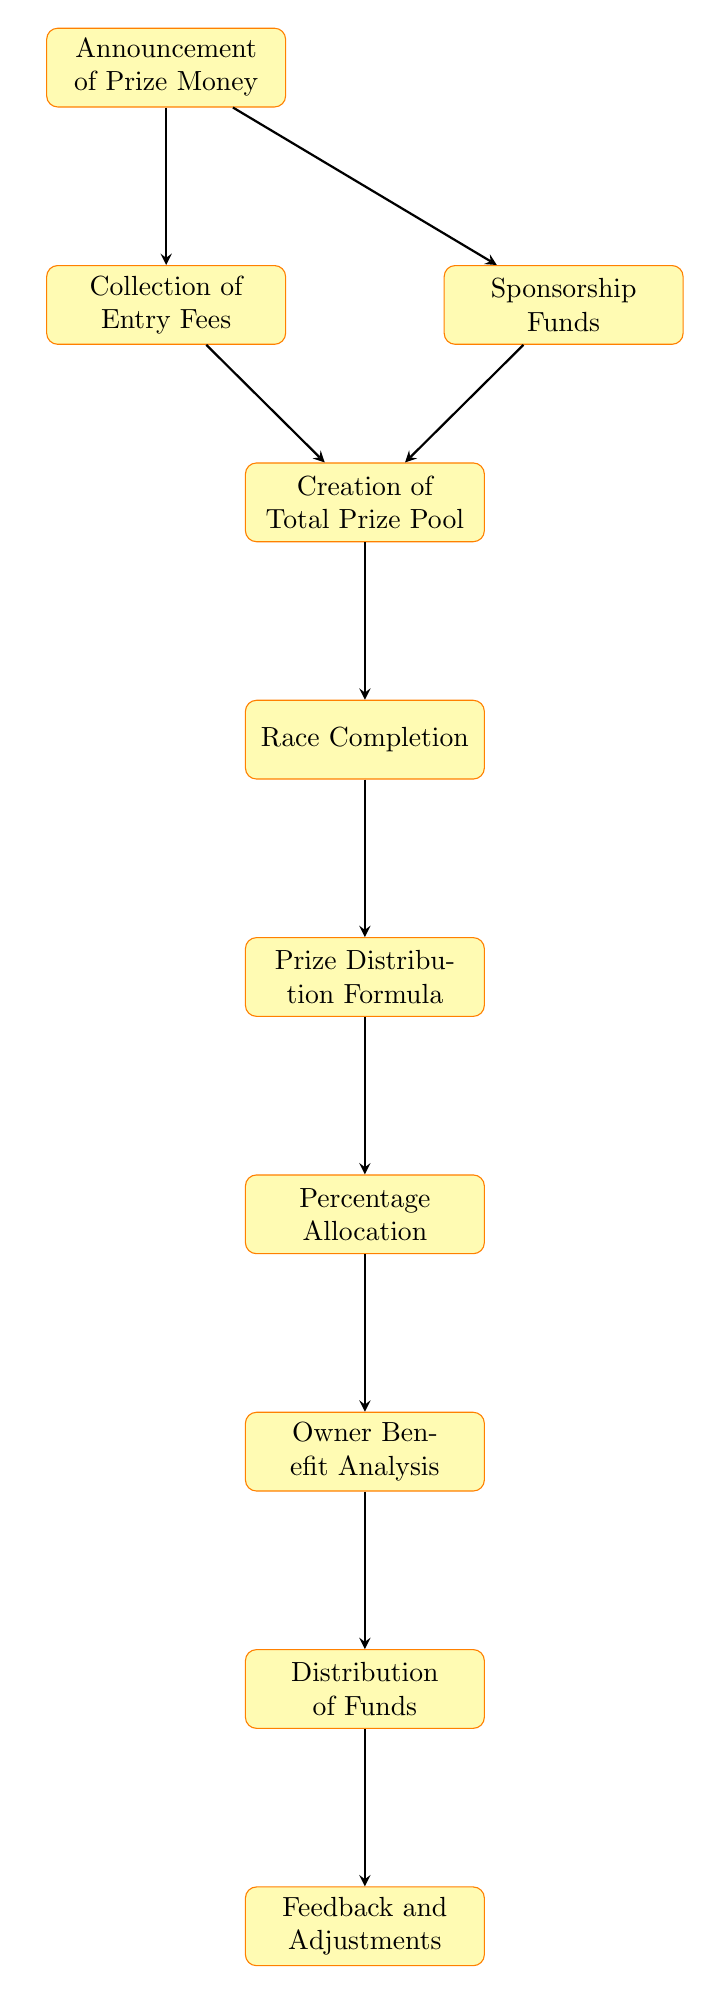What is the first step in the prize money distribution process? The diagram indicates that the first step is the "Announcement of Prize Money," as it is the starting point before any other activities occur.
Answer: Announcement of Prize Money How many main processes are represented in the flow chart? By counting the nodes in the flow chart, there are ten main processes represented, starting from the announcement and ending with feedback implementation.
Answer: 10 What happens after the Collection of Entry Fees? The diagram shows that after the "Collection of Entry Fees" is completed, the next process is the "Creation of Total Prize Pool," which involves both entry fees and sponsorship funds.
Answer: Creation of Total Prize Pool Which node directly follows the Race Completion node? According to the flow chart, the "Prize Distribution Formula" follows the "Race Completion" node directly, indicating that the prize money is distributed based on the results of the race.
Answer: Prize Distribution Formula What is the last step in the prize money distribution process? The flow chart clearly indicates that the final step in the process is "Feedback and Adjustments," which involves gathering input for future events.
Answer: Feedback and Adjustments What are the sources of the total prize pool? The total prize pool is created by combining "Entry Fees" and "Sponsorship Funds," according to the connections depicted in the flow chart.
Answer: Entry Fees and Sponsorship Funds How is the prize money divided among the winners? The flow chart specifies that a "Prize Distribution Formula" is applied following the race completion to determine how the prize money is divided among winners.
Answer: Prize Distribution Formula How many nodes represent the analysis of owner benefits? There is one node specifically designated for "Owner Benefit Analysis," which assesses the benefits that horse owners receive based on placement.
Answer: 1 What process comes after the Prize Distribution Formula? The diagram indicates that after applying the "Prize Distribution Formula," the next process is "Percentage Allocation," which details how the prize money percentages are distributed.
Answer: Percentage Allocation What is the purpose of the Feedback and Adjustments step? This step is for collecting feedback from participating owners to make necessary adjustments in future events for smoother operations and improved satisfaction.
Answer: Collect feedback for adjustments 